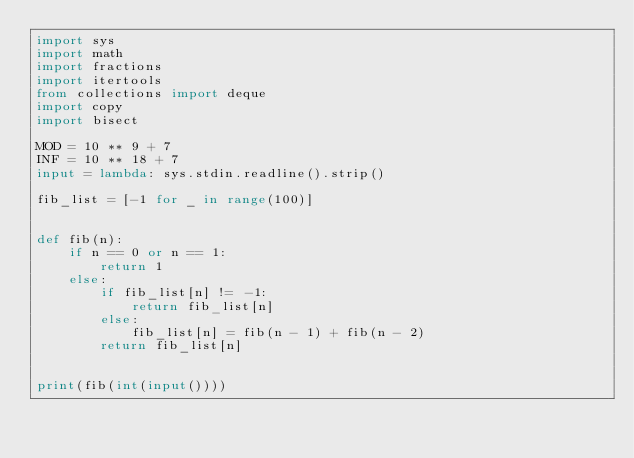<code> <loc_0><loc_0><loc_500><loc_500><_Python_>import sys
import math
import fractions
import itertools
from collections import deque
import copy
import bisect

MOD = 10 ** 9 + 7
INF = 10 ** 18 + 7
input = lambda: sys.stdin.readline().strip()

fib_list = [-1 for _ in range(100)]


def fib(n):
    if n == 0 or n == 1:
        return 1
    else:
        if fib_list[n] != -1:
            return fib_list[n]
        else:
            fib_list[n] = fib(n - 1) + fib(n - 2)
        return fib_list[n]


print(fib(int(input())))

</code> 